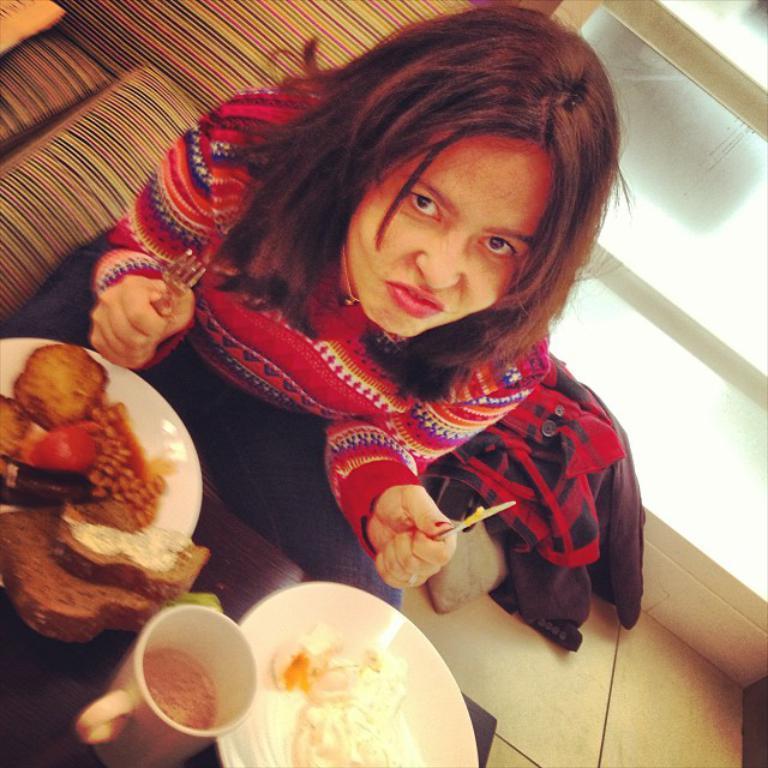Describe this image in one or two sentences. Here in this picture we can see a woman sitting over a place and in front of her we can see a table having plates of food and a cup and she is holding a fork and butter knife in her hands and making an facial expression and beside her we can see a jacket present and behind her we can see a window present. 